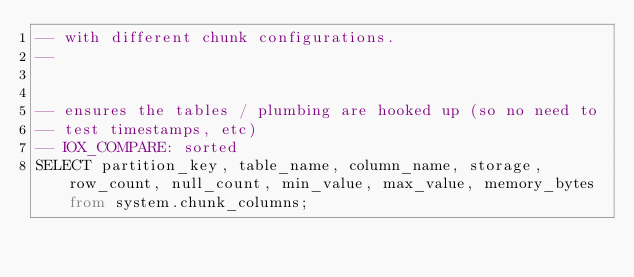Convert code to text. <code><loc_0><loc_0><loc_500><loc_500><_SQL_>-- with different chunk configurations.
--


-- ensures the tables / plumbing are hooked up (so no need to
-- test timestamps, etc)
-- IOX_COMPARE: sorted
SELECT partition_key, table_name, column_name, storage, row_count, null_count, min_value, max_value, memory_bytes from system.chunk_columns;
</code> 